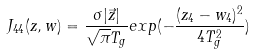Convert formula to latex. <formula><loc_0><loc_0><loc_500><loc_500>J _ { 4 4 } ( z , w ) = \frac { \sigma | \vec { z } | } { \sqrt { \pi } T _ { g } } e x p ( - \frac { ( z _ { 4 } - w _ { 4 } ) ^ { 2 } } { 4 T _ { g } ^ { 2 } } )</formula> 